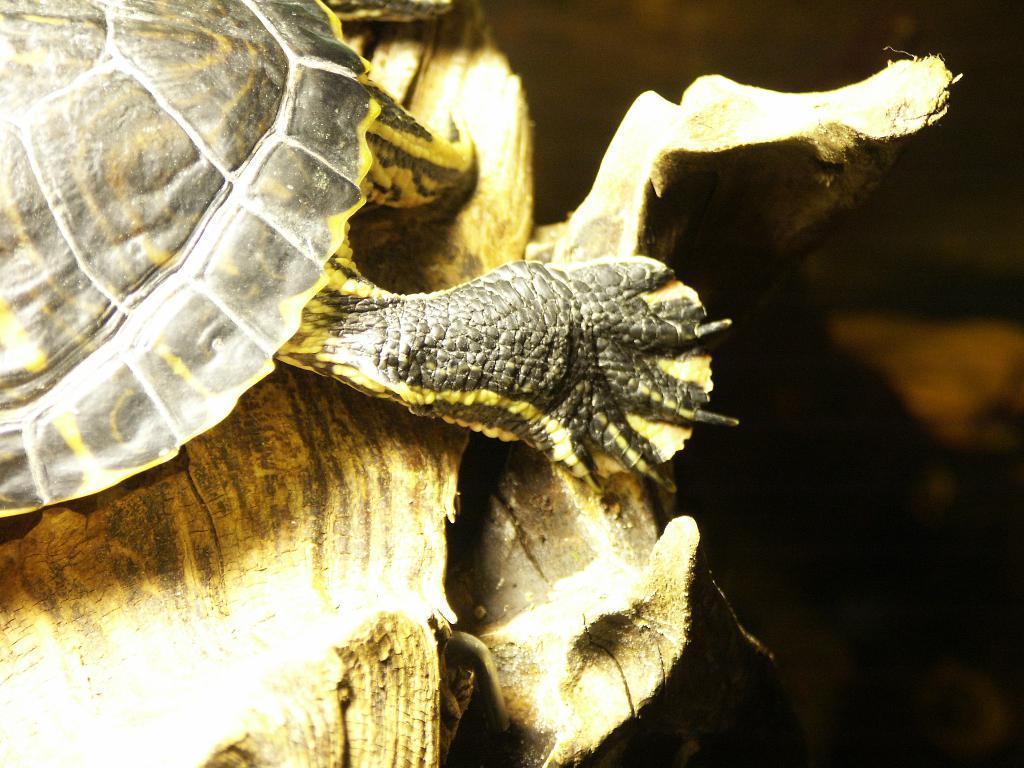Please provide a concise description of this image. On the left side of the image we can see one wooden object. On the wooden object, we can see one tortoise. In the background, we can see it is blurred. 